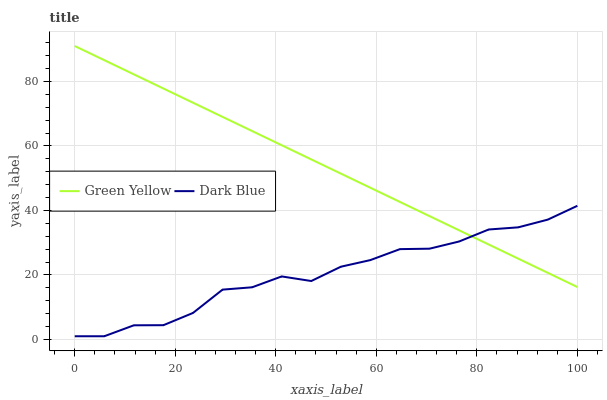Does Dark Blue have the minimum area under the curve?
Answer yes or no. Yes. Does Green Yellow have the maximum area under the curve?
Answer yes or no. Yes. Does Green Yellow have the minimum area under the curve?
Answer yes or no. No. Is Green Yellow the smoothest?
Answer yes or no. Yes. Is Dark Blue the roughest?
Answer yes or no. Yes. Is Green Yellow the roughest?
Answer yes or no. No. Does Dark Blue have the lowest value?
Answer yes or no. Yes. Does Green Yellow have the lowest value?
Answer yes or no. No. Does Green Yellow have the highest value?
Answer yes or no. Yes. Does Green Yellow intersect Dark Blue?
Answer yes or no. Yes. Is Green Yellow less than Dark Blue?
Answer yes or no. No. Is Green Yellow greater than Dark Blue?
Answer yes or no. No. 